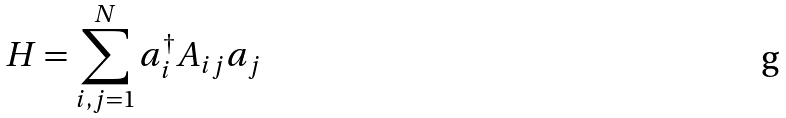Convert formula to latex. <formula><loc_0><loc_0><loc_500><loc_500>H = \sum _ { i , j = 1 } ^ { N } a ^ { \dagger } _ { i } A _ { i j } a _ { j }</formula> 